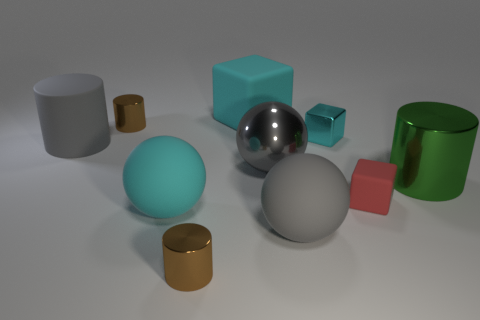Subtract all balls. How many objects are left? 7 Subtract all large green metallic cylinders. Subtract all yellow rubber spheres. How many objects are left? 9 Add 4 cylinders. How many cylinders are left? 8 Add 1 matte objects. How many matte objects exist? 6 Subtract 0 red spheres. How many objects are left? 10 